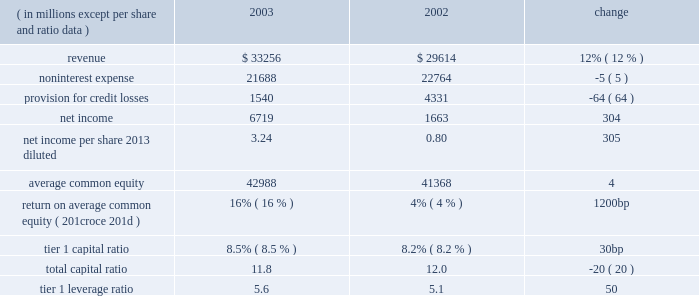Management 2019s discussion and analysis j.p .
Morgan chase & co .
22 j.p .
Morgan chase & co .
/ 2003 annual report overview j.p .
Morgan chase & co .
Is a leading global finan- cial services firm with assets of $ 771 billion and operations in more than 50 countries .
The firm serves more than 30 million consumers nationwide through its retail businesses , and many of the world's most prominent corporate , institutional and government clients through its global whole- sale businesses .
Total noninterest expense was $ 21.7 billion , down 5% ( 5 % ) from the prior year .
In 2002 , the firm recorded $ 1.3 billion of charges , princi- pally for enron-related surety litigation and the establishment of lit- igation reserves ; and $ 1.2 billion for merger and restructuring costs related to programs announced prior to january 1 , 2002 .
Excluding these costs , expenses rose by 7% ( 7 % ) in 2003 , reflecting higher per- formance-related incentives ; increased costs related to stock-based compensation and pension and other postretirement expenses ; and higher occupancy expenses .
The firm began expensing stock options in 2003 .
Restructuring costs associated with initiatives announced after january 1 , 2002 , were recorded in their relevant expense categories and totaled $ 630 million in 2003 , down 29% ( 29 % ) from 2002 .
The 2003 provision for credit losses of $ 1.5 billion was down $ 2.8 billion , or 64% ( 64 % ) , from 2002 .
The provision was lower than total net charge-offs of $ 2.3 billion , reflecting significant improvement in the quality of the commercial loan portfolio .
Commercial nonperforming assets and criticized exposure levels declined 42% ( 42 % ) and 47% ( 47 % ) , respectively , from december 31 , 2002 .
Consumer credit quality remained stable .
Earnings per diluted share ( 201ceps 201d ) for the year were $ 3.24 , an increase of 305% ( 305 % ) over the eps of $ 0.80 reported in 2002 .
Results in 2002 were provided on both a reported basis and an operating basis , which excluded merger and restructuring costs and special items .
Operating eps in 2002 was $ 1.66 .
See page 28 of this annual report for a reconciliation between reported and operating eps .
Summary of segment results the firm 2019s wholesale businesses are known globally as 201cjpmorgan , 201d and its national consumer and middle market busi- nesses are known as 201cchase . 201d the wholesale businesses com- prise four segments : the investment bank ( 201cib 201d ) , treasury & securities services ( 201ctss 201d ) , investment management & private banking ( 201cimpb 201d ) and jpmorgan partners ( 201cjpmp 201d ) .
Ib provides a full range of investment banking and commercial banking products and services , including advising on corporate strategy and structure , capital raising , risk management , and market-making in cash securities and derivative instruments in all major capital markets .
The three businesses within tss provide debt servicing , securities custody and related functions , and treasury and cash management services to corporations , financial institutions and governments .
The impb business provides invest- ment management services to institutional investors , high net worth individuals and retail customers and also provides person- alized advice and solutions to wealthy individuals and families .
Jpmp , the firm 2019s private equity business , provides equity and mez- zanine capital financing to private companies .
The firm 2019s national consumer and middle market businesses , which provide lending and full-service banking to consumers and small and middle mar- ket businesses , comprise chase financial services ( 201ccfs 201d ) .
Financial performance of jpmorgan chase as of or for the year ended december 31 .
In 2003 , global growth strengthened relative to the prior two years .
The u.s .
Economy improved significantly , supported by diminishing geopolitical uncertainties , new tax relief , strong profit growth , low interest rates and a rising stock market .
Productivity at u.s .
Businesses continued to grow at an extraor- dinary pace , as a result of ongoing investment in information technologies .
Profit margins rose to levels not seen in a long time .
New hiring remained tepid , but signs of an improving job market emerged late in the year .
Inflation fell to the lowest level in more than 40 years , and the board of governors of the federal reserve system ( the 201cfederal reserve board 201d ) declared that its long-run goal of price stability had been achieved .
Against this backdrop , j.p .
Morgan chase & co .
( 201cjpmorgan chase 201d or the 201cfirm 201d ) reported 2003 net income of $ 6.7 bil- lion , compared with net income of $ 1.7 billion in 2002 .
All five of the firm 2019s lines of business benefited from the improved eco- nomic conditions , with each reporting increased revenue over 2002 .
In particular , the low 2013interest rate environment drove robust fixed income markets and an unprecedented mortgage refinancing boom , resulting in record earnings in the investment bank and chase financial services .
Total revenue for 2003 was $ 33.3 billion , up 12% ( 12 % ) from 2002 .
The investment bank 2019s revenue increased by approximately $ 1.9 billion from 2002 , and chase financial services 2019 revenue was $ 14.6 billion in 2003 , another record year. .
What was non-interest expense as a percentage of revenue in 2002? 
Rationale: looking at this ratio for a financial institution like a bank demonstrates the leverage or lack of leverage the operations has on profitability .
Computations: (22764 / 29614)
Answer: 0.76869. 